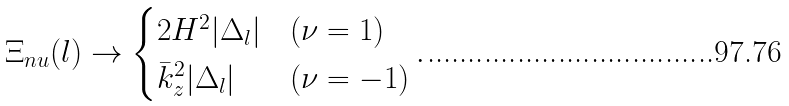Convert formula to latex. <formula><loc_0><loc_0><loc_500><loc_500>\Xi _ { n u } ( l ) \to \begin{cases} 2 H ^ { 2 } | \Delta _ { l } | & ( \nu = 1 ) \\ { \bar { k } } _ { z } ^ { 2 } | \Delta _ { l } | & ( \nu = - 1 ) \end{cases} .</formula> 